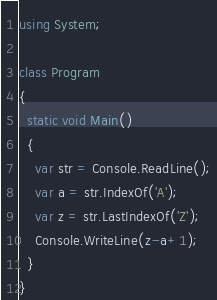Convert code to text. <code><loc_0><loc_0><loc_500><loc_500><_C#_>using System;

class Program
{
  static void Main()
  {
    var str = Console.ReadLine();
    var a = str.IndexOf('A');
    var z = str.LastIndexOf('Z');
    Console.WriteLine(z-a+1);
  }
}
</code> 